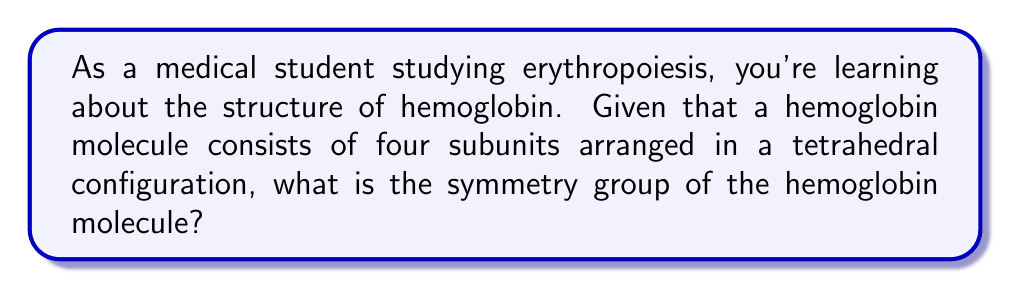Show me your answer to this math problem. To determine the symmetry group of a hemoglobin molecule, let's follow these steps:

1. Understand the structure:
   Hemoglobin consists of four subunits (two α and two β) arranged in a tetrahedral configuration.

2. Identify the symmetry operations:
   a) Rotations: The tetrahedron has four 3-fold rotational axes (through each vertex) and three 2-fold rotational axes (through the midpoints of opposite edges).
   b) Reflections: There are six reflection planes, each passing through two opposite edges.
   c) Inversion: The tetrahedron has a center of inversion.

3. Count the symmetry operations:
   - Identity: 1
   - Rotations: 8 (4 × C₃ + 3 × C₂)
   - Reflections: 6
   - Inversion: 1

4. Determine the total number of symmetry operations:
   Total = 1 + 8 + 6 + 1 = 16

5. Identify the symmetry group:
   The group with 24 elements that includes these symmetry operations is the tetrahedral group, denoted as $T_d$.

6. Relate to point groups:
   In crystallography and molecular symmetry, $T_d$ is one of the 32 crystallographic point groups.

Therefore, the symmetry group of a hemoglobin molecule, based on its tetrahedral arrangement of subunits, is the tetrahedral group $T_d$.
Answer: $T_d$ (tetrahedral group) 